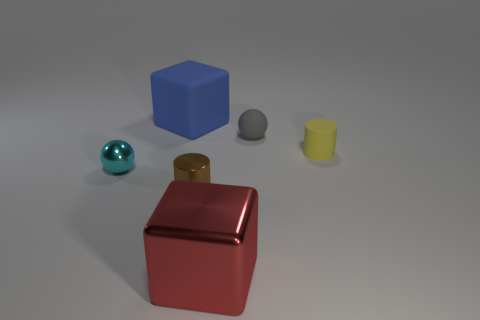Add 2 brown metallic cylinders. How many objects exist? 8 Add 6 big metal cubes. How many big metal cubes exist? 7 Subtract 0 yellow blocks. How many objects are left? 6 Subtract all cylinders. How many objects are left? 4 Subtract all green balls. Subtract all green blocks. How many balls are left? 2 Subtract all cyan shiny things. Subtract all tiny shiny balls. How many objects are left? 4 Add 2 rubber spheres. How many rubber spheres are left? 3 